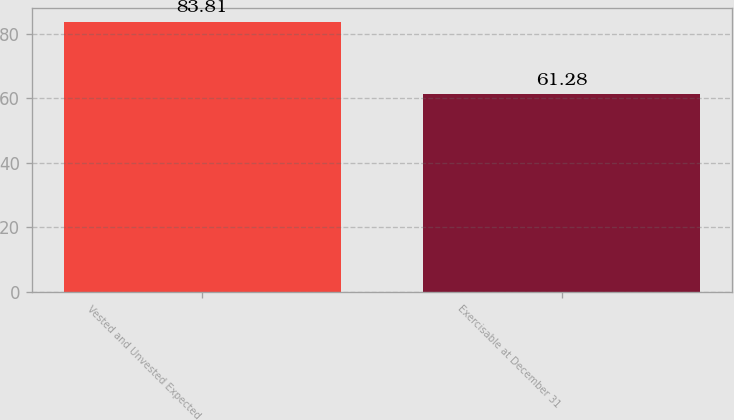Convert chart. <chart><loc_0><loc_0><loc_500><loc_500><bar_chart><fcel>Vested and Unvested Expected<fcel>Exercisable at December 31<nl><fcel>83.81<fcel>61.28<nl></chart> 